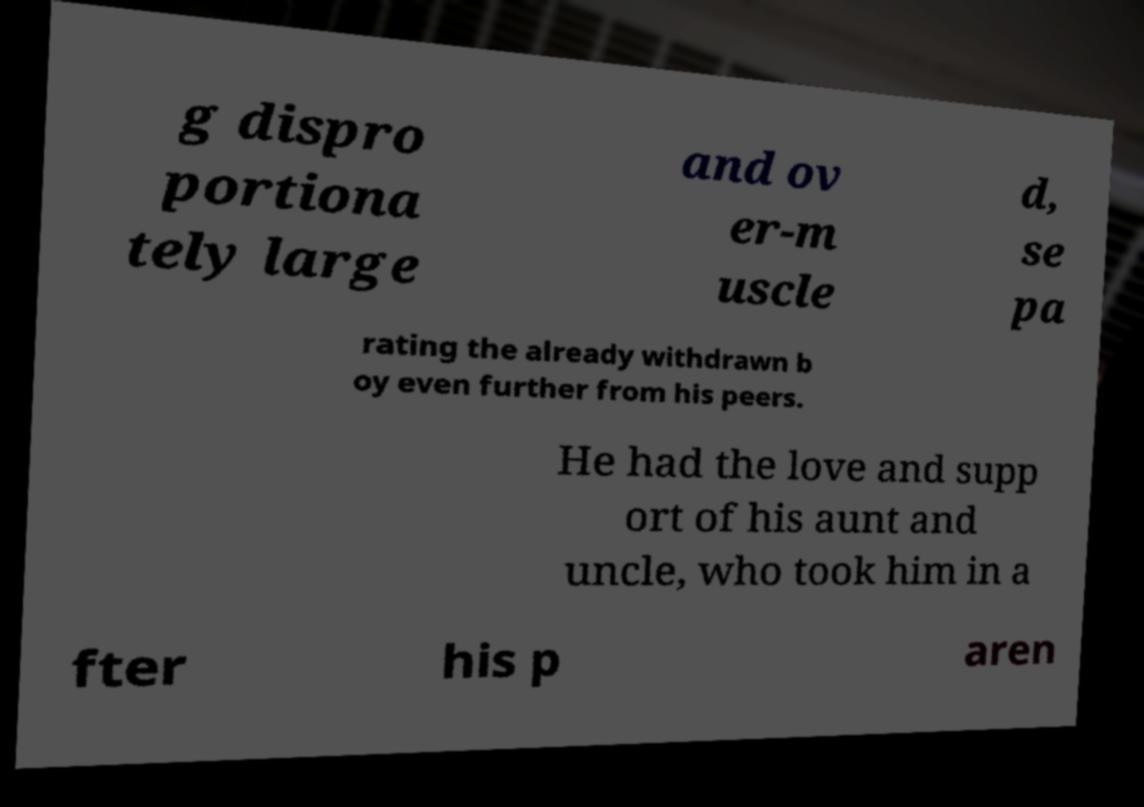I need the written content from this picture converted into text. Can you do that? g dispro portiona tely large and ov er-m uscle d, se pa rating the already withdrawn b oy even further from his peers. He had the love and supp ort of his aunt and uncle, who took him in a fter his p aren 